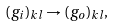<formula> <loc_0><loc_0><loc_500><loc_500>( g _ { i } ) _ { k l } \rightarrow ( g _ { o } ) _ { k l } ,</formula> 